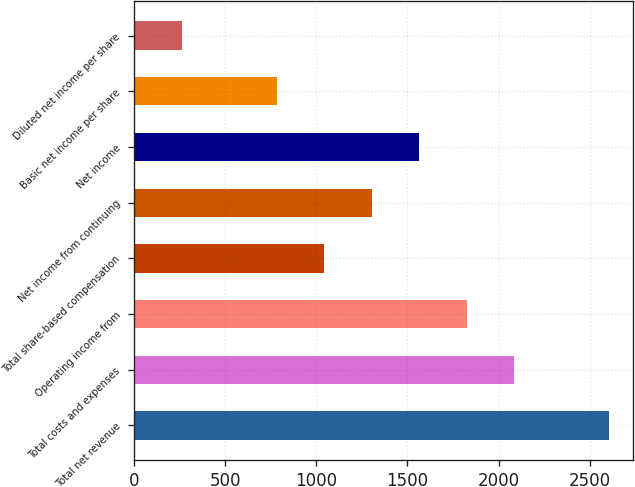Convert chart. <chart><loc_0><loc_0><loc_500><loc_500><bar_chart><fcel>Total net revenue<fcel>Total costs and expenses<fcel>Operating income from<fcel>Total share-based compensation<fcel>Net income from continuing<fcel>Net income<fcel>Basic net income per share<fcel>Diluted net income per share<nl><fcel>2606<fcel>2085.08<fcel>1824.6<fcel>1043.16<fcel>1303.64<fcel>1564.12<fcel>782.68<fcel>261.72<nl></chart> 